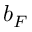<formula> <loc_0><loc_0><loc_500><loc_500>b _ { F }</formula> 